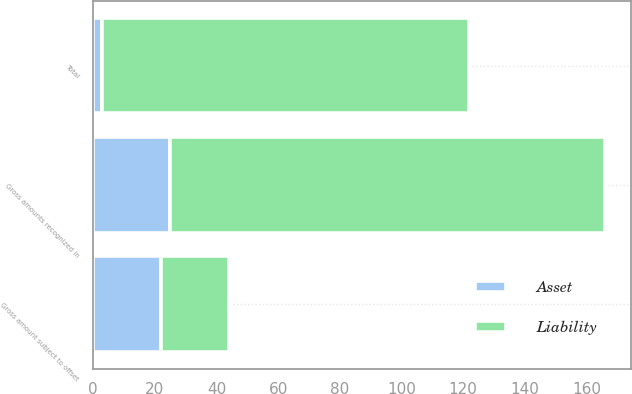Convert chart to OTSL. <chart><loc_0><loc_0><loc_500><loc_500><stacked_bar_chart><ecel><fcel>Gross amounts recognized in<fcel>Gross amount subject to offset<fcel>Total<nl><fcel>Liability<fcel>141<fcel>22<fcel>119<nl><fcel>Asset<fcel>25<fcel>22<fcel>3<nl></chart> 